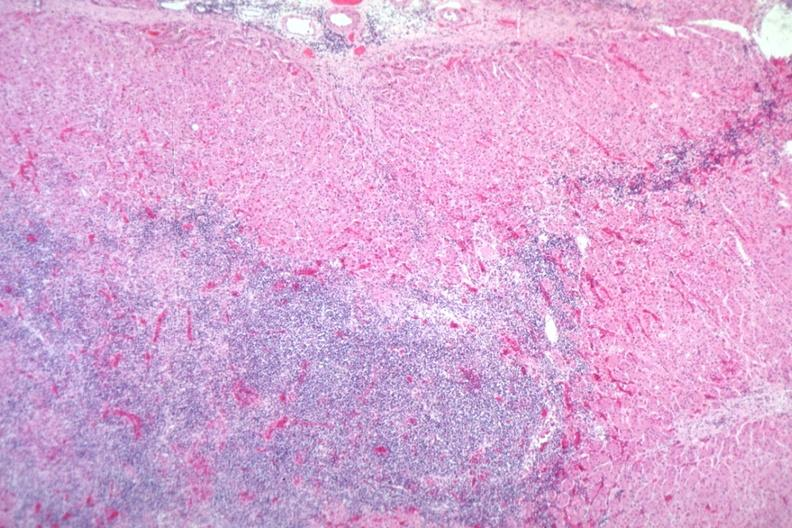s sacrococcygeal teratoma present?
Answer the question using a single word or phrase. No 